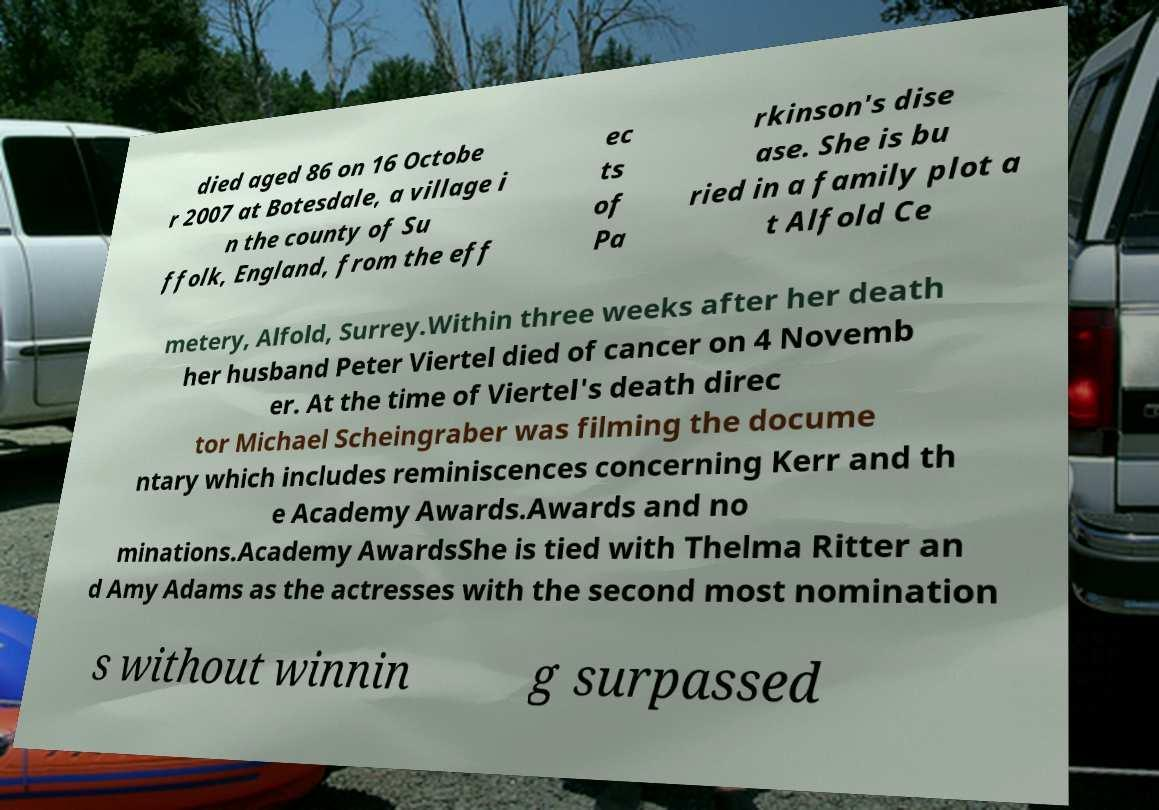Please read and relay the text visible in this image. What does it say? died aged 86 on 16 Octobe r 2007 at Botesdale, a village i n the county of Su ffolk, England, from the eff ec ts of Pa rkinson's dise ase. She is bu ried in a family plot a t Alfold Ce metery, Alfold, Surrey.Within three weeks after her death her husband Peter Viertel died of cancer on 4 Novemb er. At the time of Viertel's death direc tor Michael Scheingraber was filming the docume ntary which includes reminiscences concerning Kerr and th e Academy Awards.Awards and no minations.Academy AwardsShe is tied with Thelma Ritter an d Amy Adams as the actresses with the second most nomination s without winnin g surpassed 